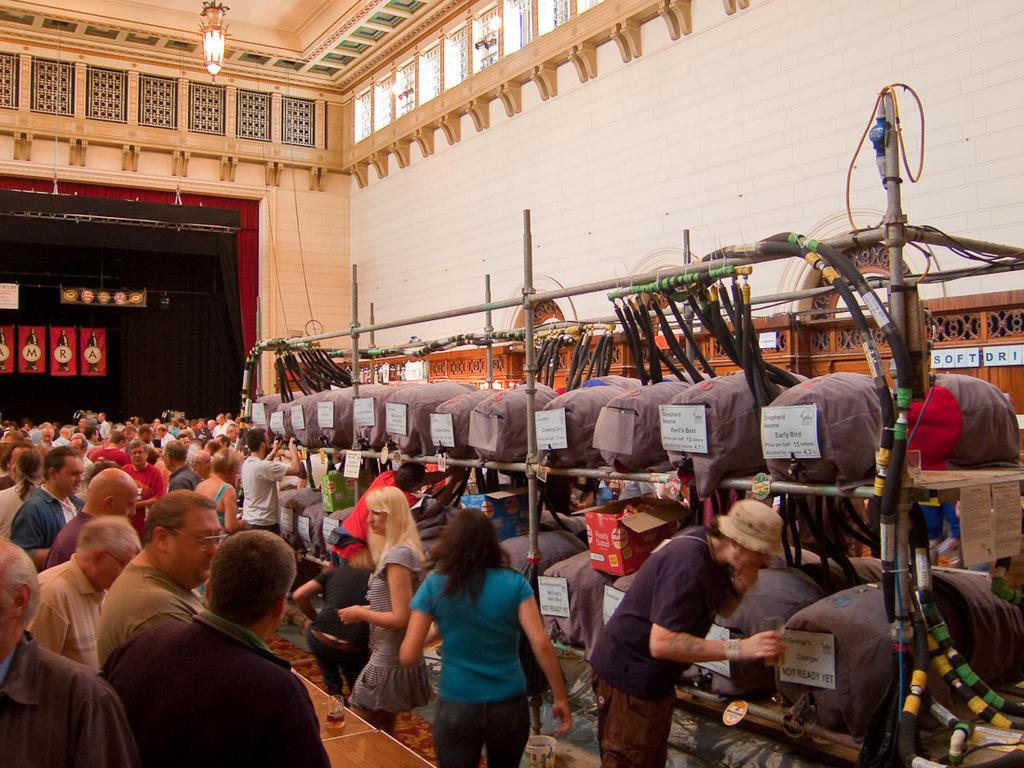How many individuals can be seen in the image? There are many people standing in the image. What is located in front of the people? There are objects arranged in a rack in front of the people. What is behind the people in the image? There is a wall behind the people. What part of the room can be seen at the top of the image? The ceiling is visible at the top of the image. What type of thunder can be heard in the image? There is no thunder present in the image, as it is a still photograph. 